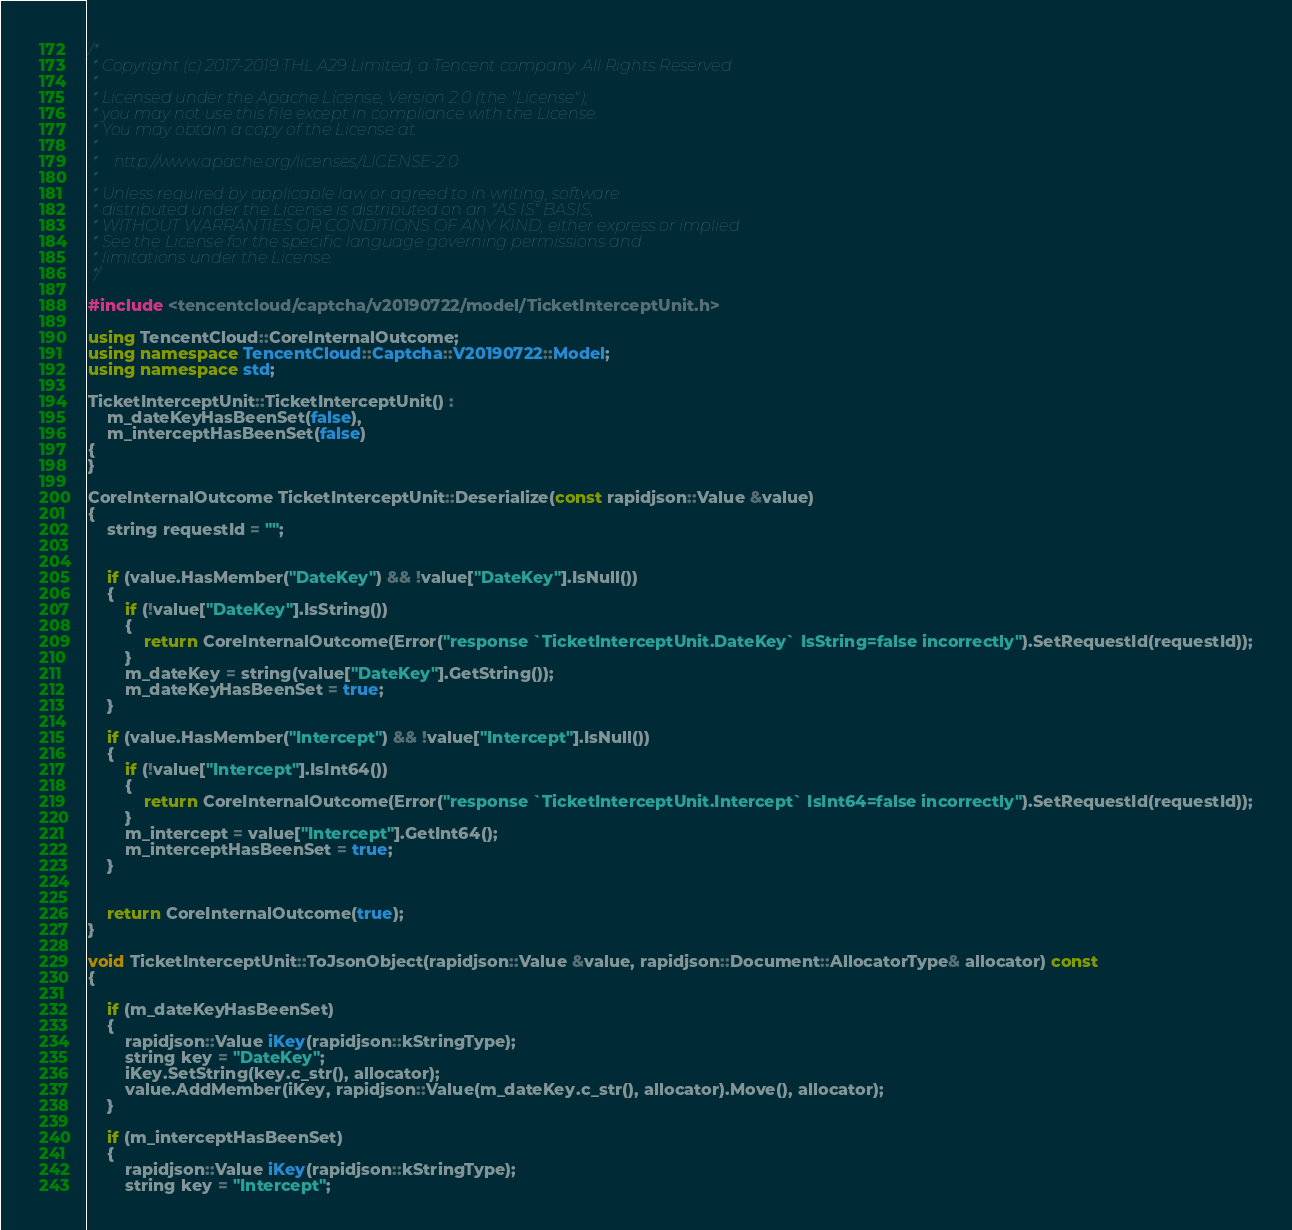Convert code to text. <code><loc_0><loc_0><loc_500><loc_500><_C++_>/*
 * Copyright (c) 2017-2019 THL A29 Limited, a Tencent company. All Rights Reserved.
 *
 * Licensed under the Apache License, Version 2.0 (the "License");
 * you may not use this file except in compliance with the License.
 * You may obtain a copy of the License at
 *
 *    http://www.apache.org/licenses/LICENSE-2.0
 *
 * Unless required by applicable law or agreed to in writing, software
 * distributed under the License is distributed on an "AS IS" BASIS,
 * WITHOUT WARRANTIES OR CONDITIONS OF ANY KIND, either express or implied.
 * See the License for the specific language governing permissions and
 * limitations under the License.
 */

#include <tencentcloud/captcha/v20190722/model/TicketInterceptUnit.h>

using TencentCloud::CoreInternalOutcome;
using namespace TencentCloud::Captcha::V20190722::Model;
using namespace std;

TicketInterceptUnit::TicketInterceptUnit() :
    m_dateKeyHasBeenSet(false),
    m_interceptHasBeenSet(false)
{
}

CoreInternalOutcome TicketInterceptUnit::Deserialize(const rapidjson::Value &value)
{
    string requestId = "";


    if (value.HasMember("DateKey") && !value["DateKey"].IsNull())
    {
        if (!value["DateKey"].IsString())
        {
            return CoreInternalOutcome(Error("response `TicketInterceptUnit.DateKey` IsString=false incorrectly").SetRequestId(requestId));
        }
        m_dateKey = string(value["DateKey"].GetString());
        m_dateKeyHasBeenSet = true;
    }

    if (value.HasMember("Intercept") && !value["Intercept"].IsNull())
    {
        if (!value["Intercept"].IsInt64())
        {
            return CoreInternalOutcome(Error("response `TicketInterceptUnit.Intercept` IsInt64=false incorrectly").SetRequestId(requestId));
        }
        m_intercept = value["Intercept"].GetInt64();
        m_interceptHasBeenSet = true;
    }


    return CoreInternalOutcome(true);
}

void TicketInterceptUnit::ToJsonObject(rapidjson::Value &value, rapidjson::Document::AllocatorType& allocator) const
{

    if (m_dateKeyHasBeenSet)
    {
        rapidjson::Value iKey(rapidjson::kStringType);
        string key = "DateKey";
        iKey.SetString(key.c_str(), allocator);
        value.AddMember(iKey, rapidjson::Value(m_dateKey.c_str(), allocator).Move(), allocator);
    }

    if (m_interceptHasBeenSet)
    {
        rapidjson::Value iKey(rapidjson::kStringType);
        string key = "Intercept";</code> 